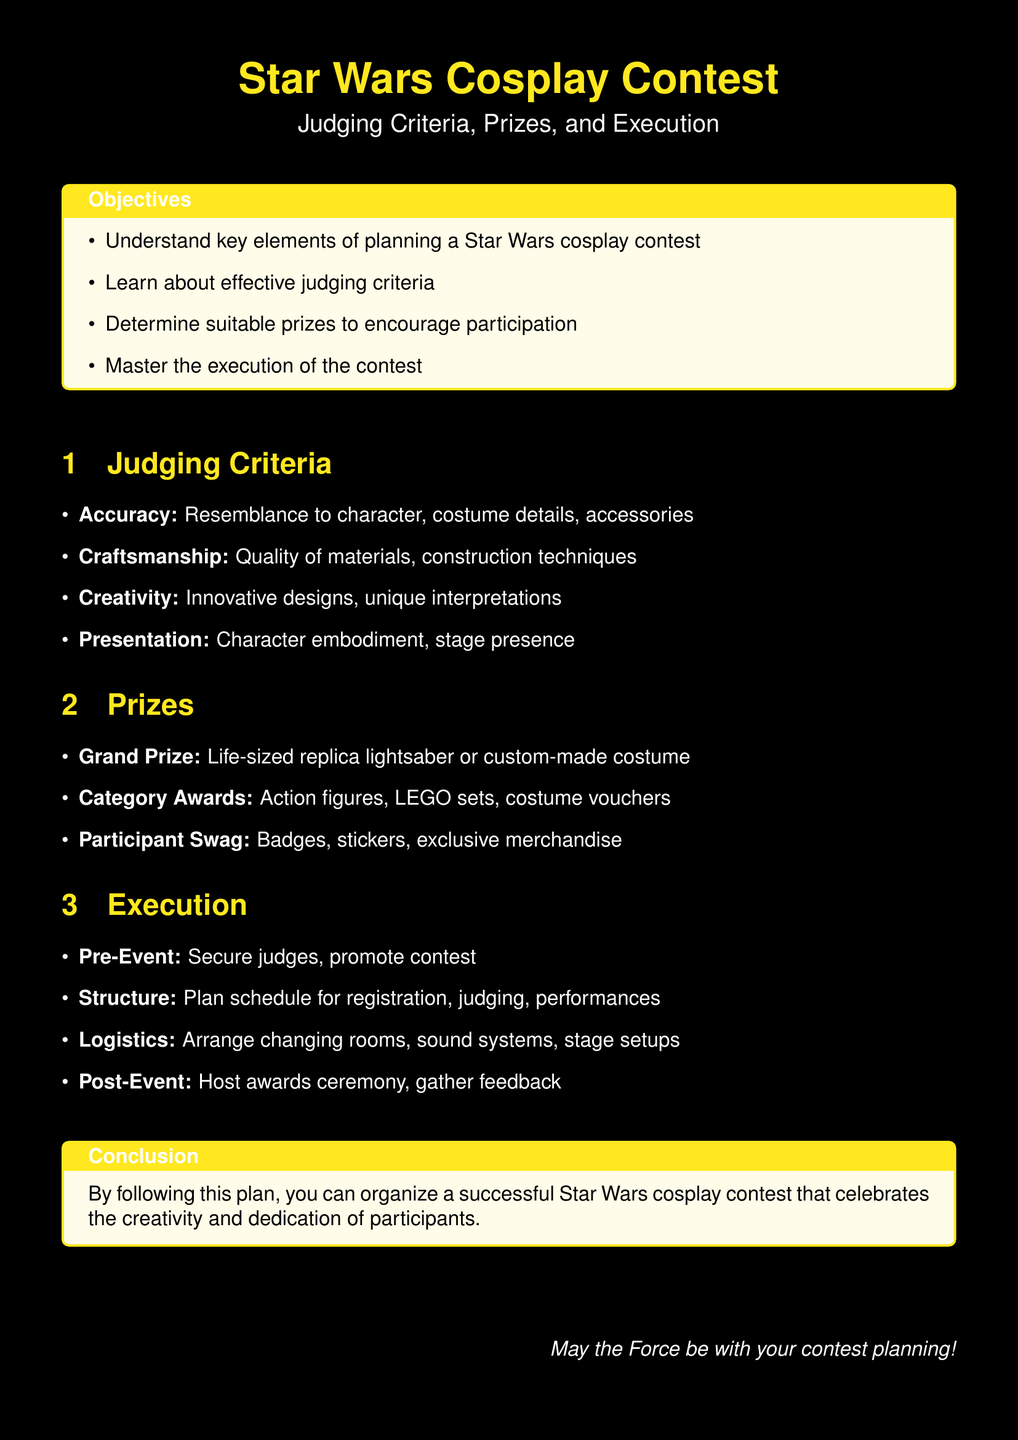What are the key elements of planning a Star Wars cosplay contest? The key elements are understanding judging criteria, determining suitable prizes, and mastering execution.
Answer: Judging criteria, Prizes, Execution What is the Grand Prize? The Grand Prize is listed as a specific item in the document.
Answer: Life-sized replica lightsaber or custom-made costume How many judging criteria are there? The document lists the judging criteria in an itemized format, indicating how many specific criteria are mentioned.
Answer: Four What is one aspect of craftsmanship according to the judging criteria? Craftsmanship includes specific quality indicators mentioned in the document.
Answer: Quality of materials What is a prize that participants will receive? The document outlines different types of participant incentives, including one specific type.
Answer: Badges What should be secured in the pre-event phase? The pre-event phase details one major preparation step that is crucial for the contest.
Answer: Judges What is included in the post-event activities? The post-event section indicates what should happen after the contest is over.
Answer: Host awards ceremony What color is the page background? The document specifies the color choice for the background, clarifying the visual design aspect.
Answer: Black What is the main purpose of the document? The document's introduction provides insight into its overall aim and function for organizers.
Answer: Organize a successful Star Wars cosplay contest 